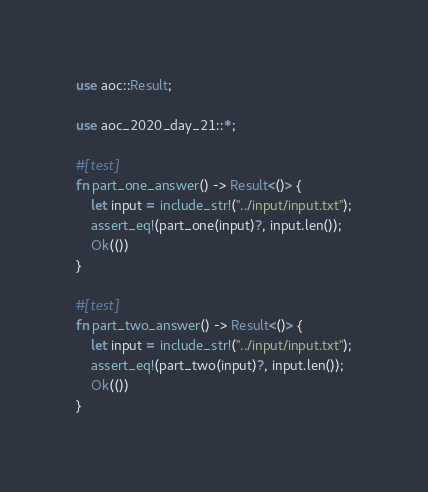Convert code to text. <code><loc_0><loc_0><loc_500><loc_500><_Rust_>use aoc::Result;

use aoc_2020_day_21::*;

#[test]
fn part_one_answer() -> Result<()> {
    let input = include_str!("../input/input.txt");
    assert_eq!(part_one(input)?, input.len());
    Ok(())
}

#[test]
fn part_two_answer() -> Result<()> {
    let input = include_str!("../input/input.txt");
    assert_eq!(part_two(input)?, input.len());
    Ok(())
}
</code> 